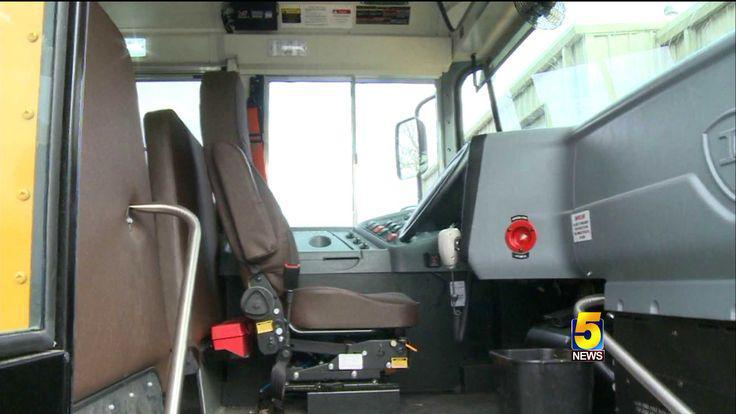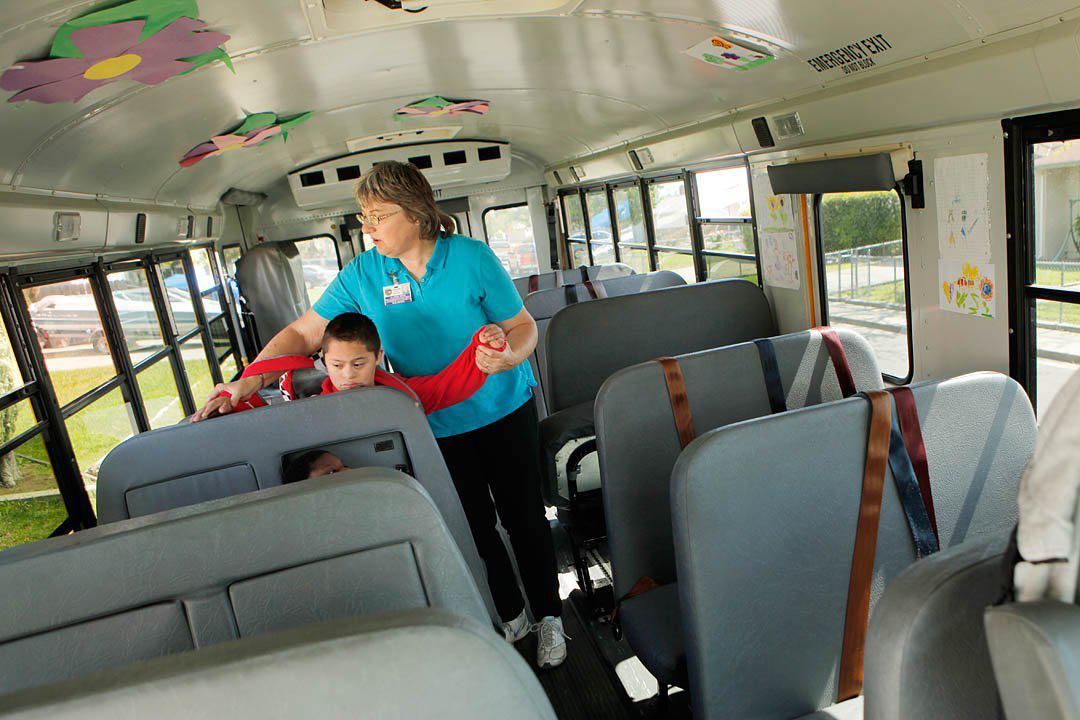The first image is the image on the left, the second image is the image on the right. Analyze the images presented: Is the assertion "In one of the images the steering wheel is visible." valid? Answer yes or no. Yes. The first image is the image on the left, the second image is the image on the right. For the images shown, is this caption "One image shows a head-on view of the aisle inside a bus, which has grayish seats and black seatbelts with bright yellow locking mechanisms." true? Answer yes or no. No. 